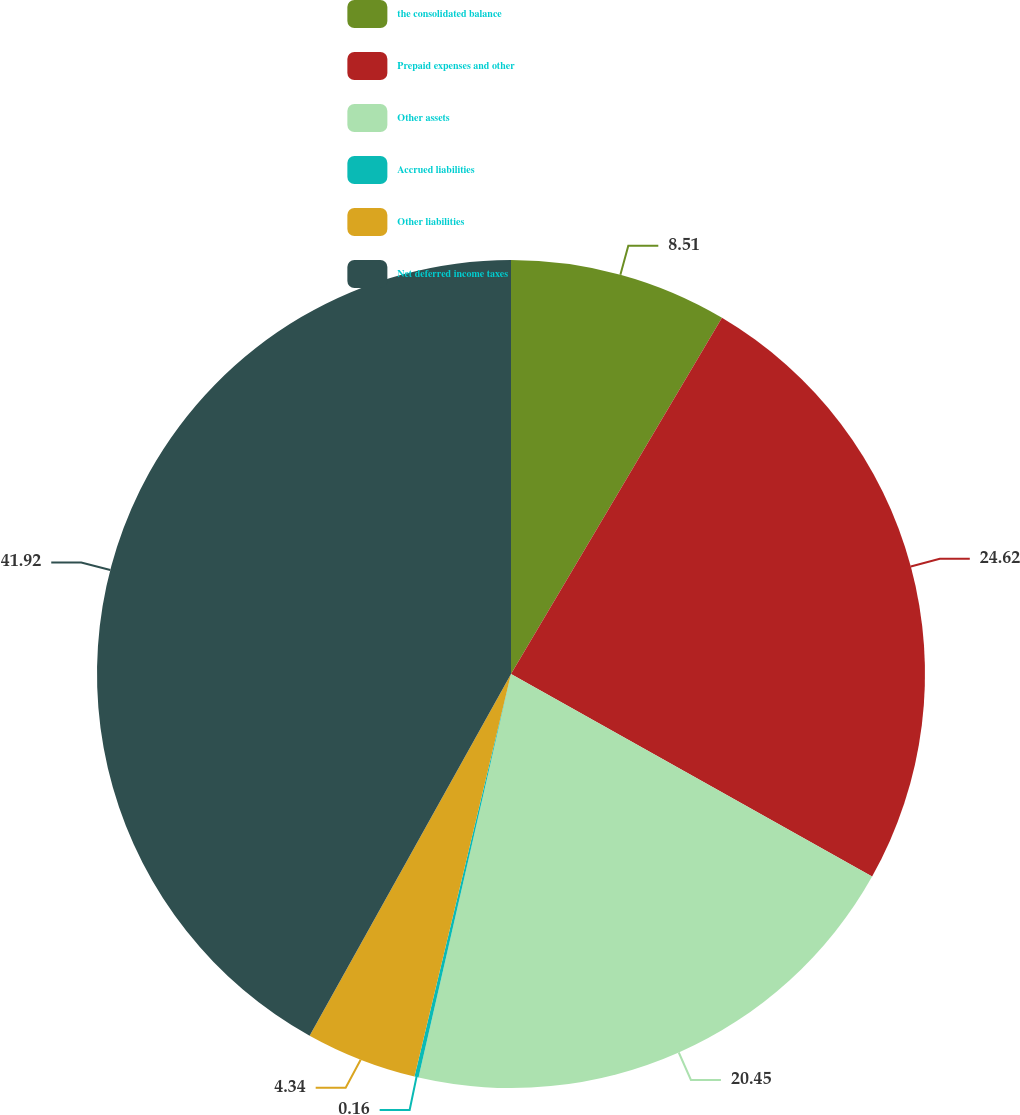Convert chart. <chart><loc_0><loc_0><loc_500><loc_500><pie_chart><fcel>the consolidated balance<fcel>Prepaid expenses and other<fcel>Other assets<fcel>Accrued liabilities<fcel>Other liabilities<fcel>Net deferred income taxes<nl><fcel>8.51%<fcel>24.62%<fcel>20.45%<fcel>0.16%<fcel>4.34%<fcel>41.91%<nl></chart> 